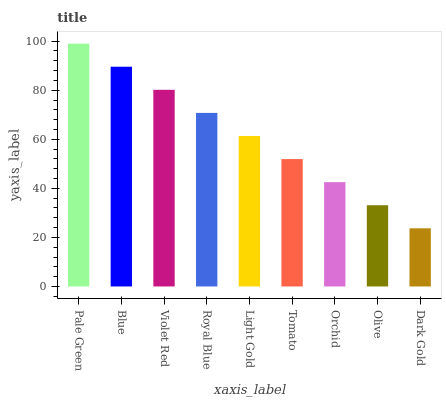Is Dark Gold the minimum?
Answer yes or no. Yes. Is Pale Green the maximum?
Answer yes or no. Yes. Is Blue the minimum?
Answer yes or no. No. Is Blue the maximum?
Answer yes or no. No. Is Pale Green greater than Blue?
Answer yes or no. Yes. Is Blue less than Pale Green?
Answer yes or no. Yes. Is Blue greater than Pale Green?
Answer yes or no. No. Is Pale Green less than Blue?
Answer yes or no. No. Is Light Gold the high median?
Answer yes or no. Yes. Is Light Gold the low median?
Answer yes or no. Yes. Is Royal Blue the high median?
Answer yes or no. No. Is Violet Red the low median?
Answer yes or no. No. 